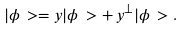<formula> <loc_0><loc_0><loc_500><loc_500>| \phi \, > = y | \phi \, > + \, y ^ { \perp } | \phi \, > .</formula> 